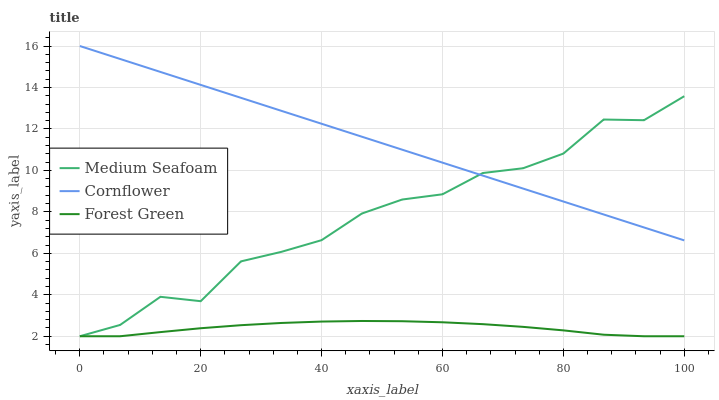Does Forest Green have the minimum area under the curve?
Answer yes or no. Yes. Does Cornflower have the maximum area under the curve?
Answer yes or no. Yes. Does Medium Seafoam have the minimum area under the curve?
Answer yes or no. No. Does Medium Seafoam have the maximum area under the curve?
Answer yes or no. No. Is Cornflower the smoothest?
Answer yes or no. Yes. Is Medium Seafoam the roughest?
Answer yes or no. Yes. Is Forest Green the smoothest?
Answer yes or no. No. Is Forest Green the roughest?
Answer yes or no. No. Does Cornflower have the highest value?
Answer yes or no. Yes. Does Medium Seafoam have the highest value?
Answer yes or no. No. Is Forest Green less than Cornflower?
Answer yes or no. Yes. Is Cornflower greater than Forest Green?
Answer yes or no. Yes. Does Forest Green intersect Cornflower?
Answer yes or no. No. 